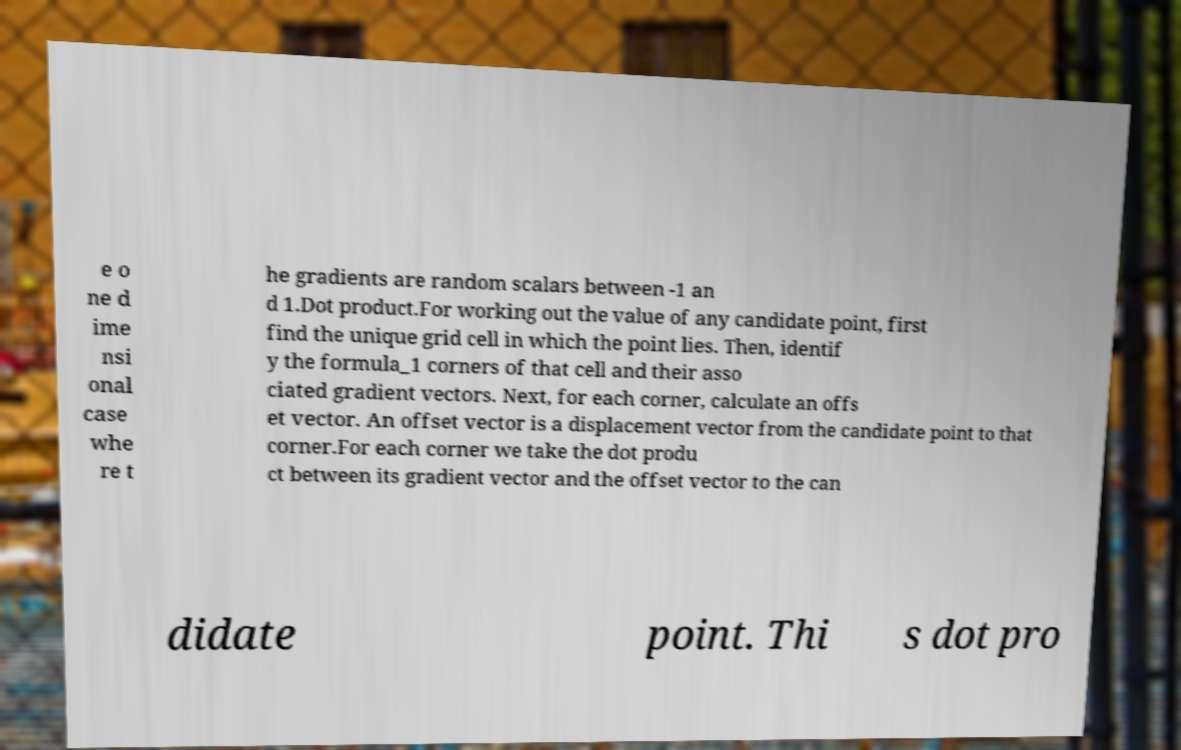Please read and relay the text visible in this image. What does it say? e o ne d ime nsi onal case whe re t he gradients are random scalars between -1 an d 1.Dot product.For working out the value of any candidate point, first find the unique grid cell in which the point lies. Then, identif y the formula_1 corners of that cell and their asso ciated gradient vectors. Next, for each corner, calculate an offs et vector. An offset vector is a displacement vector from the candidate point to that corner.For each corner we take the dot produ ct between its gradient vector and the offset vector to the can didate point. Thi s dot pro 